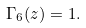Convert formula to latex. <formula><loc_0><loc_0><loc_500><loc_500>\Gamma _ { 6 } ( z ) = 1 .</formula> 